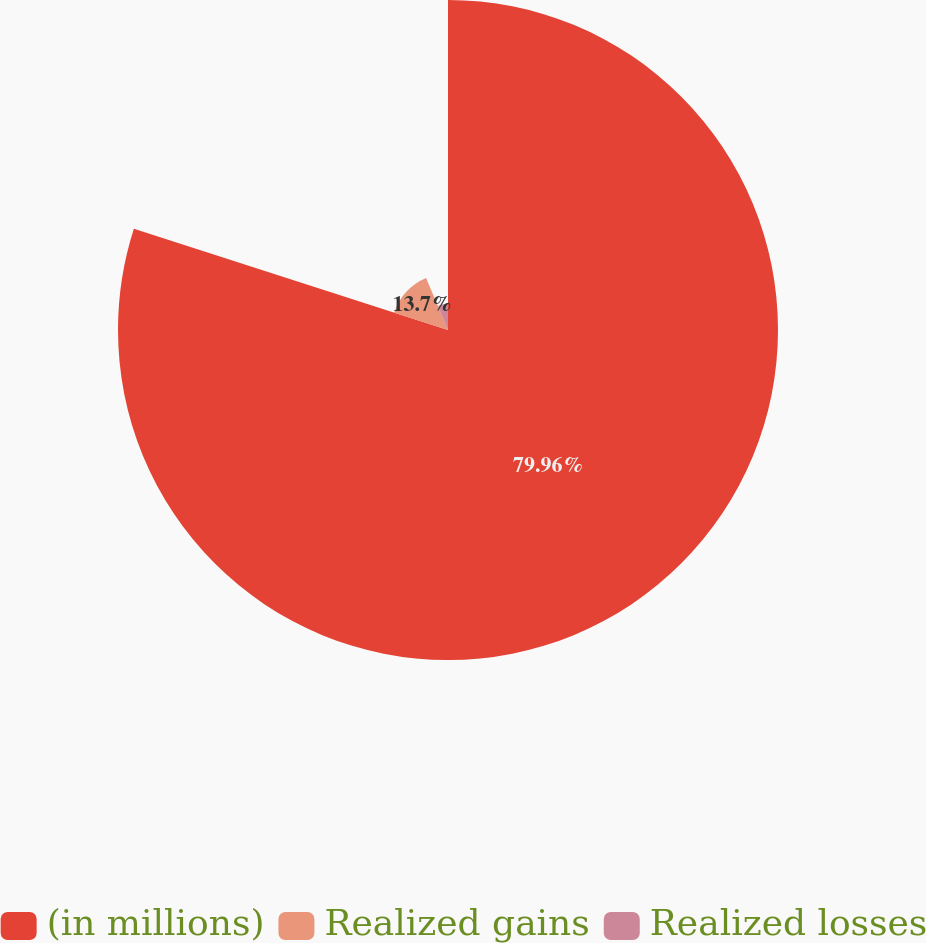<chart> <loc_0><loc_0><loc_500><loc_500><pie_chart><fcel>(in millions)<fcel>Realized gains<fcel>Realized losses<nl><fcel>79.95%<fcel>13.7%<fcel>6.34%<nl></chart> 